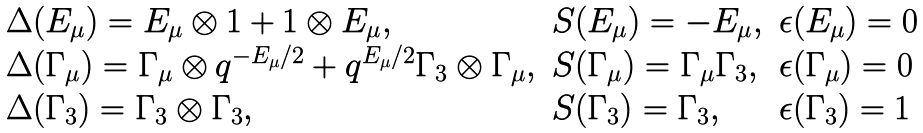<formula> <loc_0><loc_0><loc_500><loc_500>\begin{array} { l l l } \Delta ( E _ { \mu } ) = E _ { \mu } \otimes { 1 } + { 1 } \otimes E _ { \mu } , & S ( E _ { \mu } ) = - E _ { \mu } , & \epsilon ( E _ { \mu } ) = 0 \\ \Delta ( \Gamma _ { \mu } ) = \Gamma _ { \mu } \otimes q ^ { - E _ { \mu } / 2 } + q ^ { E _ { \mu } / 2 } \Gamma _ { 3 } \otimes \Gamma _ { \mu } , & S ( \Gamma _ { \mu } ) = \Gamma _ { \mu } \Gamma _ { 3 } , & \epsilon ( \Gamma _ { \mu } ) = 0 \\ \Delta ( \Gamma _ { 3 } ) = \Gamma _ { 3 } \otimes \Gamma _ { 3 } , & S ( \Gamma _ { 3 } ) = \Gamma _ { 3 } , & \epsilon ( \Gamma _ { 3 } ) = 1 \\ \end{array}</formula> 